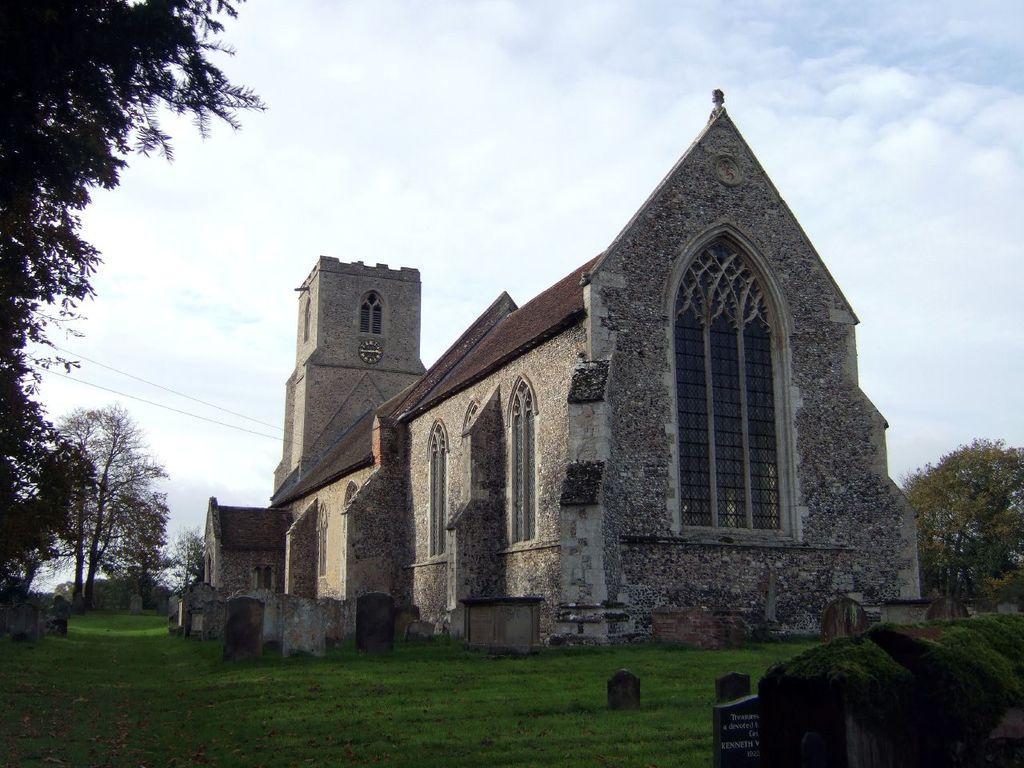Please provide a concise description of this image. In this image there is a monument and there are trees visible in this image. At the top there is sky with clouds and at the bottom there is grass. 